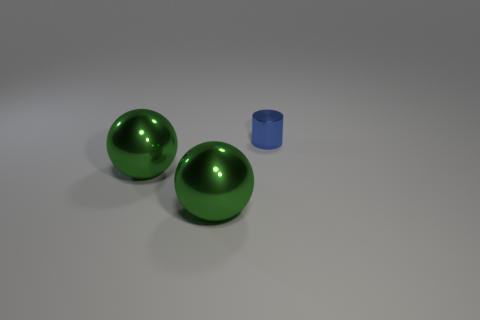Add 1 metal objects. How many objects exist? 4 Subtract all spheres. How many objects are left? 1 Add 1 tiny blue metal things. How many tiny blue metal things are left? 2 Add 2 big blue cylinders. How many big blue cylinders exist? 2 Subtract 0 brown balls. How many objects are left? 3 Subtract all big green balls. Subtract all blue cylinders. How many objects are left? 0 